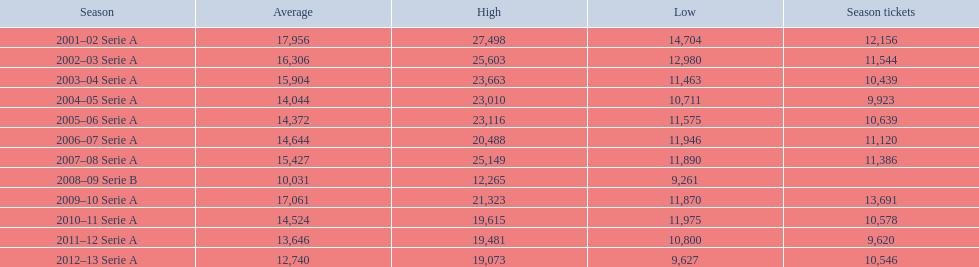When did each of the seasons take place? 2001–02 Serie A, 2002–03 Serie A, 2003–04 Serie A, 2004–05 Serie A, 2005–06 Serie A, 2006–07 Serie A, 2007–08 Serie A, 2008–09 Serie B, 2009–10 Serie A, 2010–11 Serie A, 2011–12 Serie A, 2012–13 Serie A. What was the total number of tickets sold? 12,156, 11,544, 10,439, 9,923, 10,639, 11,120, 11,386, , 13,691, 10,578, 9,620, 10,546. Specifically, how many were sold in the 2007 season? 11,386. 